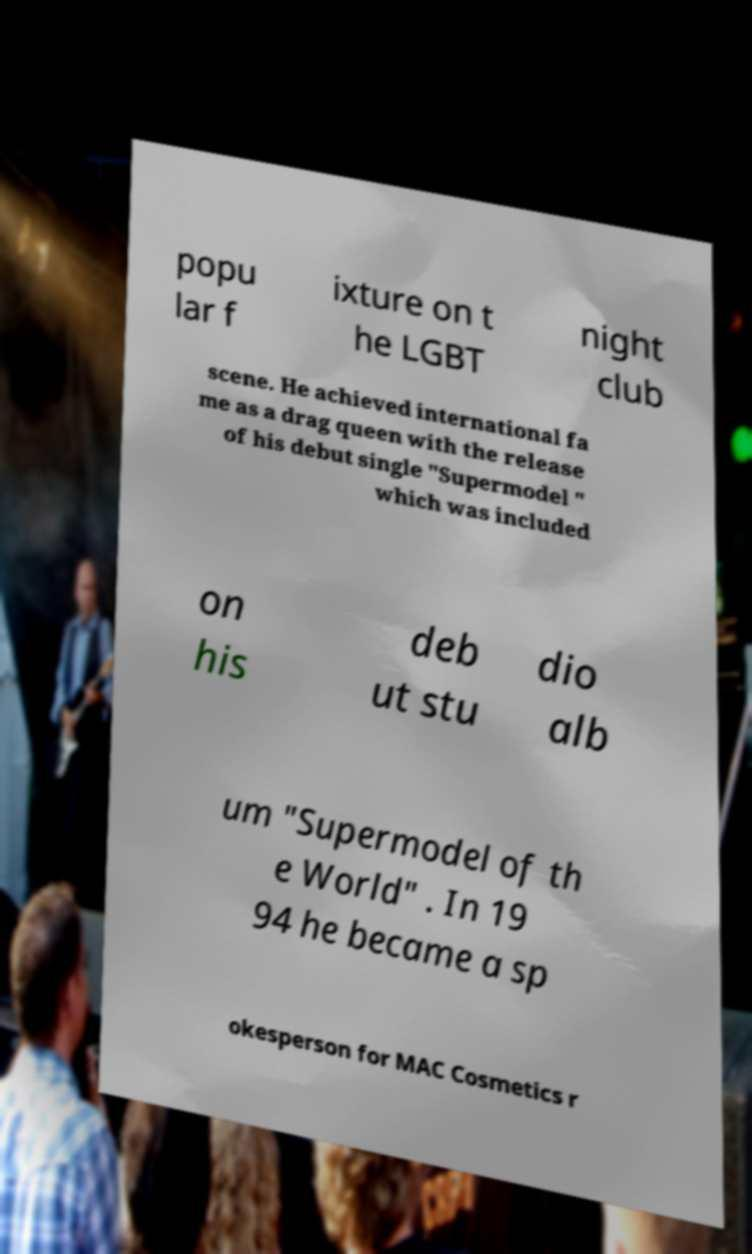Please identify and transcribe the text found in this image. popu lar f ixture on t he LGBT night club scene. He achieved international fa me as a drag queen with the release of his debut single "Supermodel " which was included on his deb ut stu dio alb um "Supermodel of th e World" . In 19 94 he became a sp okesperson for MAC Cosmetics r 